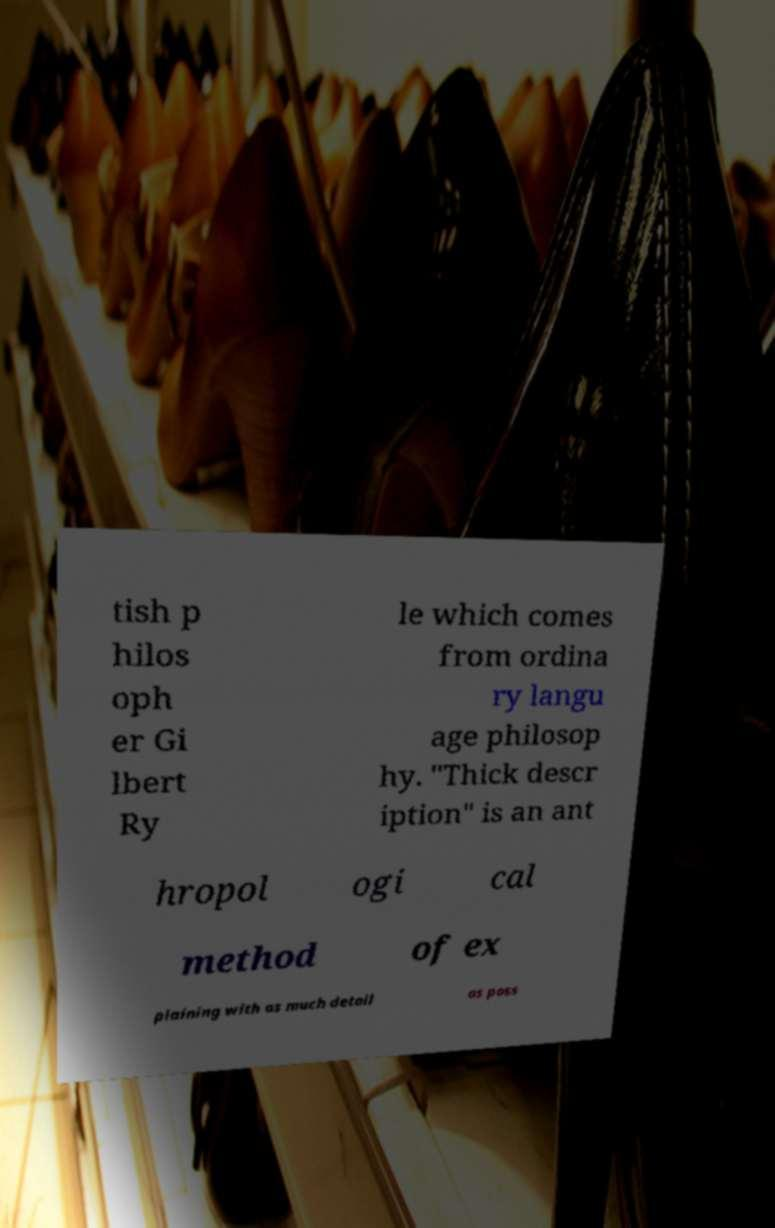Please read and relay the text visible in this image. What does it say? tish p hilos oph er Gi lbert Ry le which comes from ordina ry langu age philosop hy. "Thick descr iption" is an ant hropol ogi cal method of ex plaining with as much detail as poss 